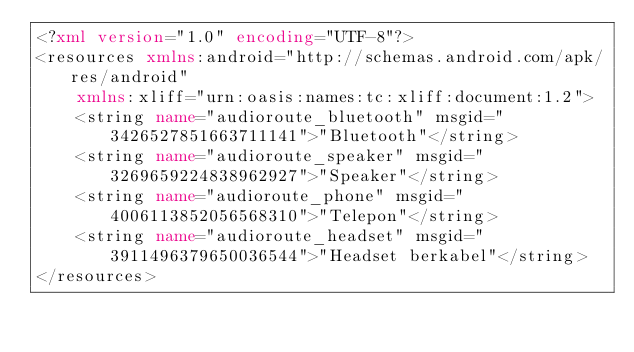<code> <loc_0><loc_0><loc_500><loc_500><_XML_><?xml version="1.0" encoding="UTF-8"?>
<resources xmlns:android="http://schemas.android.com/apk/res/android"
    xmlns:xliff="urn:oasis:names:tc:xliff:document:1.2">
    <string name="audioroute_bluetooth" msgid="3426527851663711141">"Bluetooth"</string>
    <string name="audioroute_speaker" msgid="3269659224838962927">"Speaker"</string>
    <string name="audioroute_phone" msgid="4006113852056568310">"Telepon"</string>
    <string name="audioroute_headset" msgid="3911496379650036544">"Headset berkabel"</string>
</resources>
</code> 